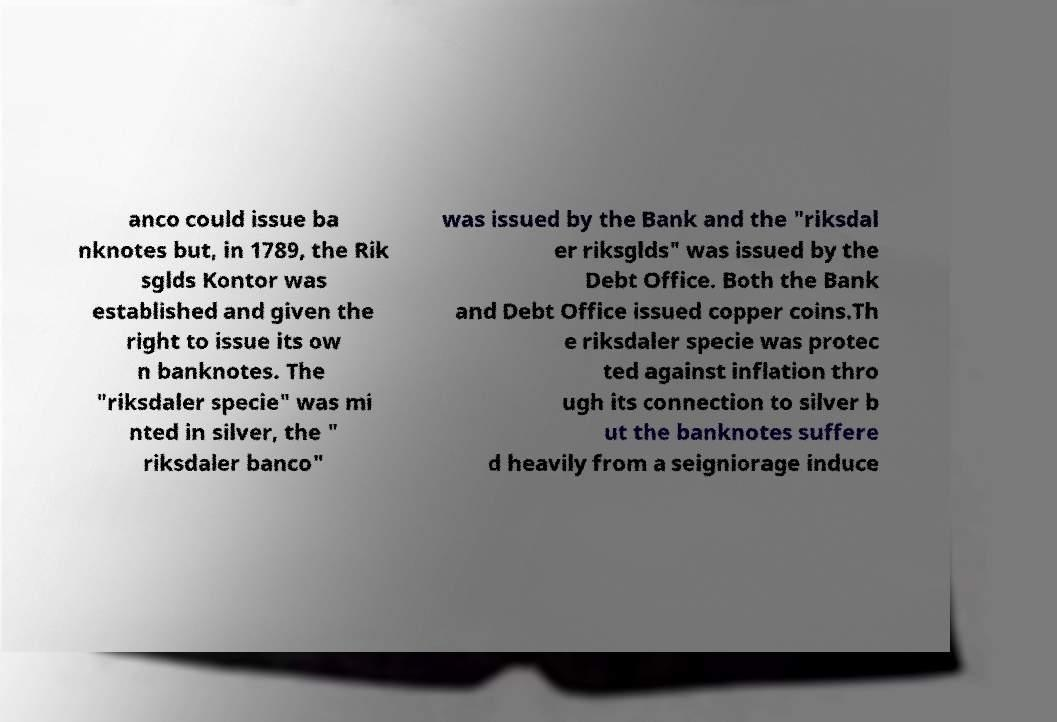There's text embedded in this image that I need extracted. Can you transcribe it verbatim? anco could issue ba nknotes but, in 1789, the Rik sglds Kontor was established and given the right to issue its ow n banknotes. The "riksdaler specie" was mi nted in silver, the " riksdaler banco" was issued by the Bank and the "riksdal er riksglds" was issued by the Debt Office. Both the Bank and Debt Office issued copper coins.Th e riksdaler specie was protec ted against inflation thro ugh its connection to silver b ut the banknotes suffere d heavily from a seigniorage induce 